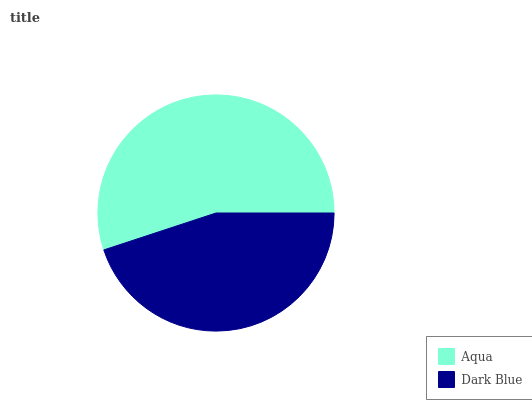Is Dark Blue the minimum?
Answer yes or no. Yes. Is Aqua the maximum?
Answer yes or no. Yes. Is Dark Blue the maximum?
Answer yes or no. No. Is Aqua greater than Dark Blue?
Answer yes or no. Yes. Is Dark Blue less than Aqua?
Answer yes or no. Yes. Is Dark Blue greater than Aqua?
Answer yes or no. No. Is Aqua less than Dark Blue?
Answer yes or no. No. Is Aqua the high median?
Answer yes or no. Yes. Is Dark Blue the low median?
Answer yes or no. Yes. Is Dark Blue the high median?
Answer yes or no. No. Is Aqua the low median?
Answer yes or no. No. 